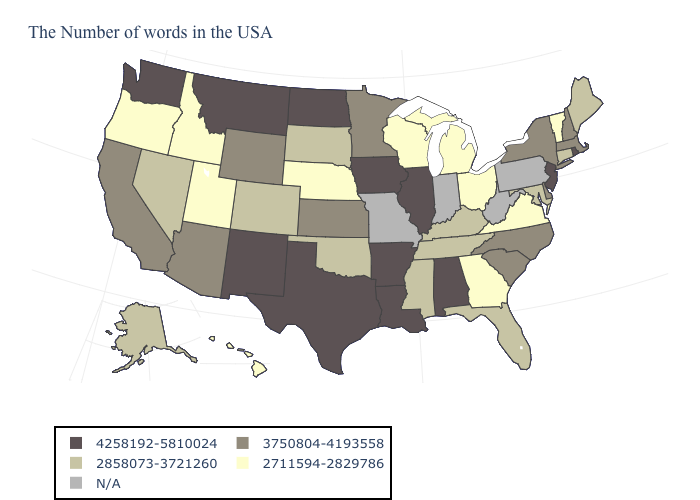Name the states that have a value in the range 4258192-5810024?
Short answer required. Rhode Island, New Jersey, Alabama, Illinois, Louisiana, Arkansas, Iowa, Texas, North Dakota, New Mexico, Montana, Washington. What is the value of Kentucky?
Concise answer only. 2858073-3721260. Which states hav the highest value in the South?
Keep it brief. Alabama, Louisiana, Arkansas, Texas. What is the lowest value in the USA?
Write a very short answer. 2711594-2829786. Which states have the highest value in the USA?
Answer briefly. Rhode Island, New Jersey, Alabama, Illinois, Louisiana, Arkansas, Iowa, Texas, North Dakota, New Mexico, Montana, Washington. Name the states that have a value in the range N/A?
Short answer required. Pennsylvania, West Virginia, Indiana, Missouri. Does Georgia have the lowest value in the USA?
Be succinct. Yes. Name the states that have a value in the range 2858073-3721260?
Quick response, please. Maine, Connecticut, Maryland, Florida, Kentucky, Tennessee, Mississippi, Oklahoma, South Dakota, Colorado, Nevada, Alaska. Among the states that border North Dakota , which have the lowest value?
Write a very short answer. South Dakota. Is the legend a continuous bar?
Concise answer only. No. What is the lowest value in the USA?
Answer briefly. 2711594-2829786. Name the states that have a value in the range 3750804-4193558?
Quick response, please. Massachusetts, New Hampshire, New York, Delaware, North Carolina, South Carolina, Minnesota, Kansas, Wyoming, Arizona, California. What is the value of New Jersey?
Write a very short answer. 4258192-5810024. 